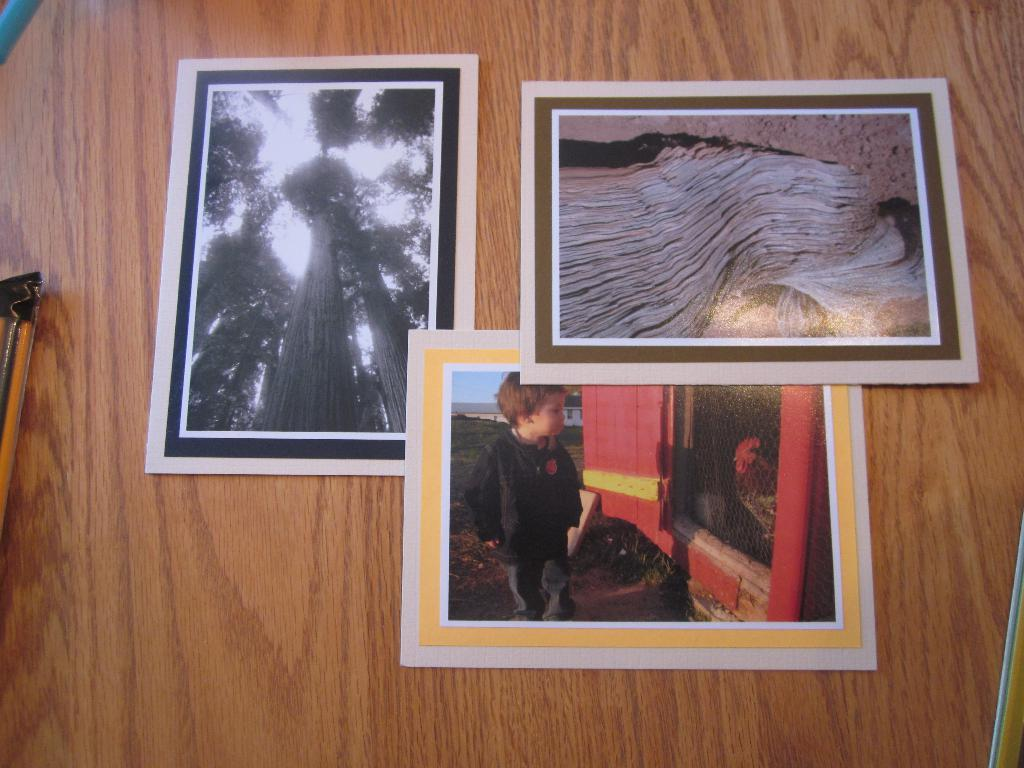What is located in the center of the image? There are posters in the center of the image. What type of steel is used to create the ghost in the image? There is no steel or ghost present in the image; it only features posters. 